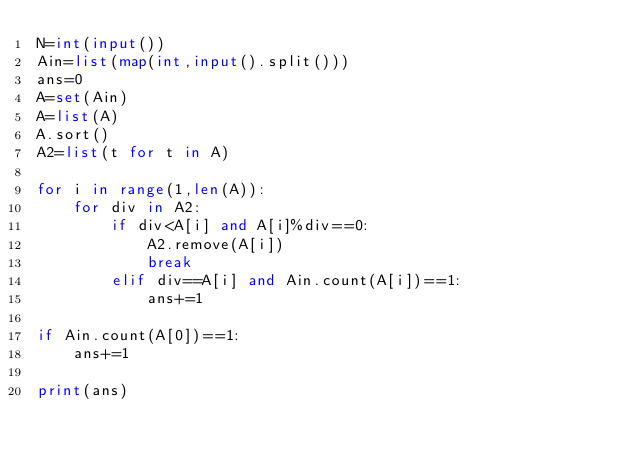<code> <loc_0><loc_0><loc_500><loc_500><_Python_>N=int(input())
Ain=list(map(int,input().split())) 
ans=0
A=set(Ain)
A=list(A)
A.sort()
A2=list(t for t in A)

for i in range(1,len(A)):
    for div in A2:
        if div<A[i] and A[i]%div==0:
            A2.remove(A[i])
            break
        elif div==A[i] and Ain.count(A[i])==1:
            ans+=1

if Ain.count(A[0])==1:
    ans+=1

print(ans)</code> 